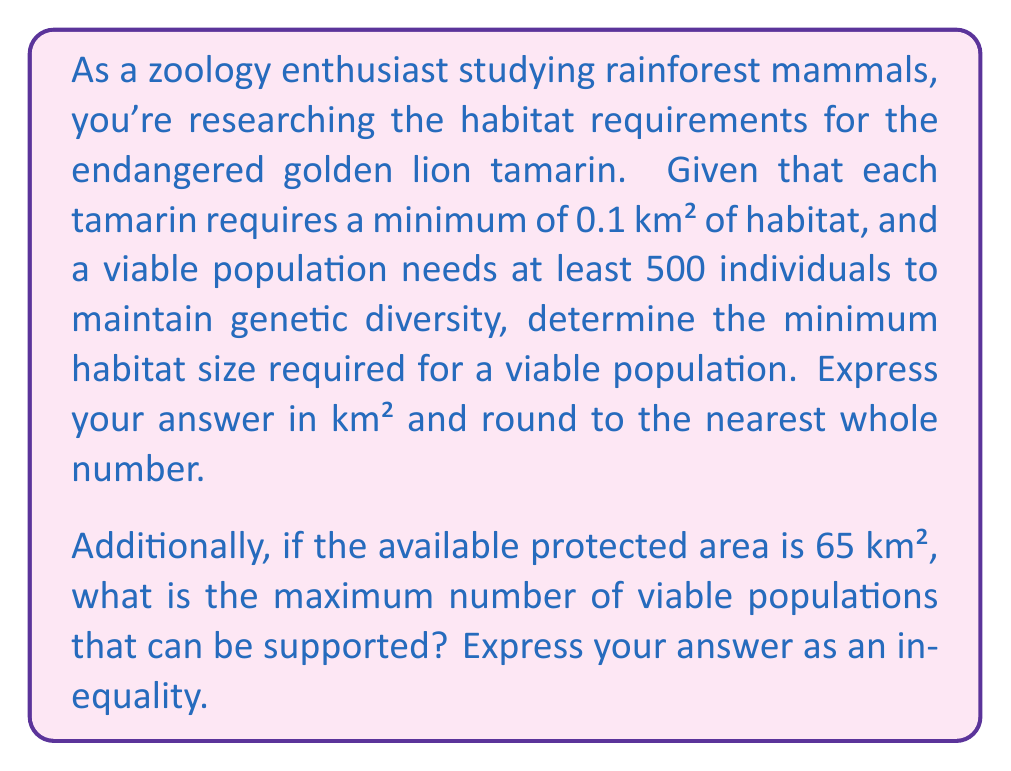Can you answer this question? Let's approach this problem step-by-step:

1) First, we need to calculate the minimum habitat size for a viable population:
   - Each tamarin requires 0.1 km²
   - A viable population needs at least 500 individuals
   
   Therefore, the minimum habitat size is:
   $$ 0.1 \text{ km}² \times 500 = 50 \text{ km}² $$

2) Rounding to the nearest whole number, we get 50 km².

3) Now, for the second part of the question, we need to determine how many viable populations can be supported in a 65 km² area.

4) Let $x$ be the number of viable populations. Each viable population requires 50 km².
   So, we can set up the following inequality:
   $$ 50x \leq 65 $$

5) Solving for $x$:
   $$ x \leq \frac{65}{50} = 1.3 $$

6) Since $x$ represents the number of populations, it must be a whole number.
   Therefore, the maximum number of viable populations is 1.

7) We can express this as an inequality:
   $$ 0 \leq x \leq 1 $$
   where $x$ is an integer.
Answer: The minimum habitat size required for a viable population of golden lion tamarins is 50 km².

The maximum number of viable populations that can be supported in the 65 km² protected area can be expressed as the inequality:
$$ 0 \leq x \leq 1 $$
where $x$ is an integer representing the number of viable populations. 